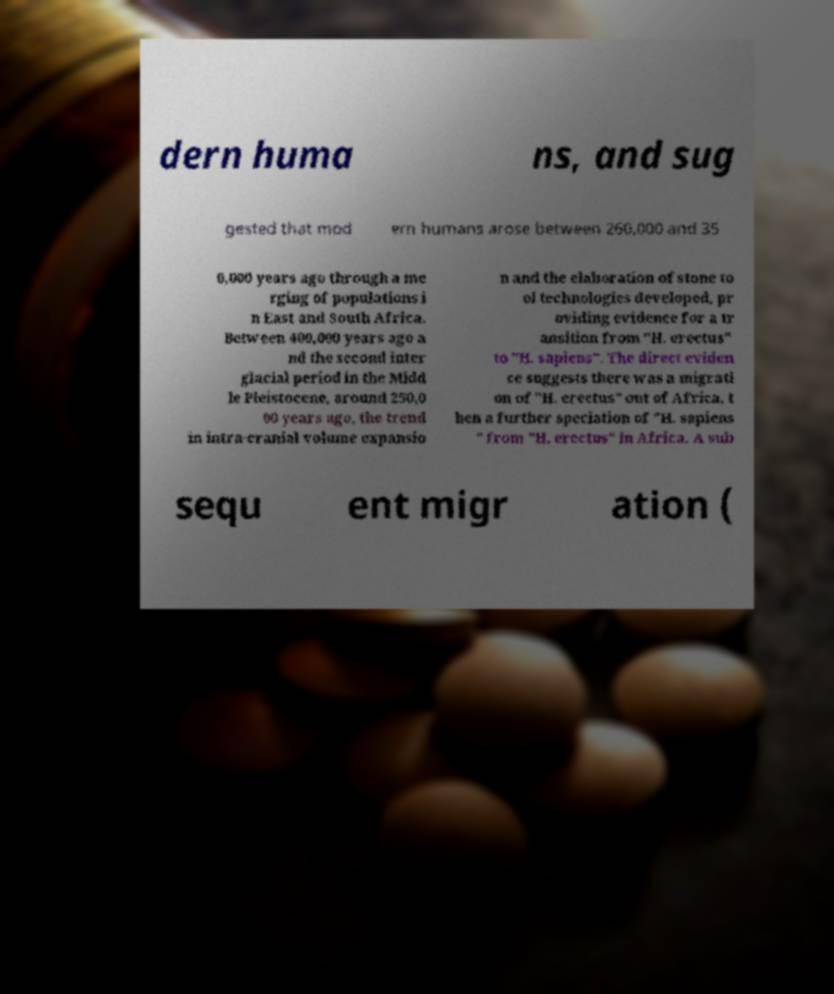Could you assist in decoding the text presented in this image and type it out clearly? dern huma ns, and sug gested that mod ern humans arose between 260,000 and 35 0,000 years ago through a me rging of populations i n East and South Africa. Between 400,000 years ago a nd the second inter glacial period in the Midd le Pleistocene, around 250,0 00 years ago, the trend in intra-cranial volume expansio n and the elaboration of stone to ol technologies developed, pr oviding evidence for a tr ansition from "H. erectus" to "H. sapiens". The direct eviden ce suggests there was a migrati on of "H. erectus" out of Africa, t hen a further speciation of "H. sapiens " from "H. erectus" in Africa. A sub sequ ent migr ation ( 